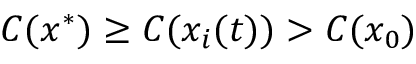<formula> <loc_0><loc_0><loc_500><loc_500>C ( x ^ { * } ) \geq C ( x _ { i } ( t ) ) > C ( x _ { 0 } )</formula> 